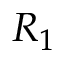<formula> <loc_0><loc_0><loc_500><loc_500>R _ { 1 }</formula> 